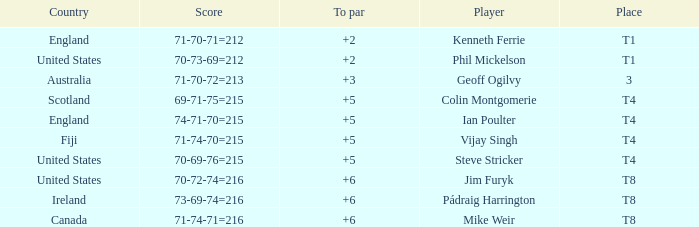Who had a score of 70-73-69=212? Phil Mickelson. 